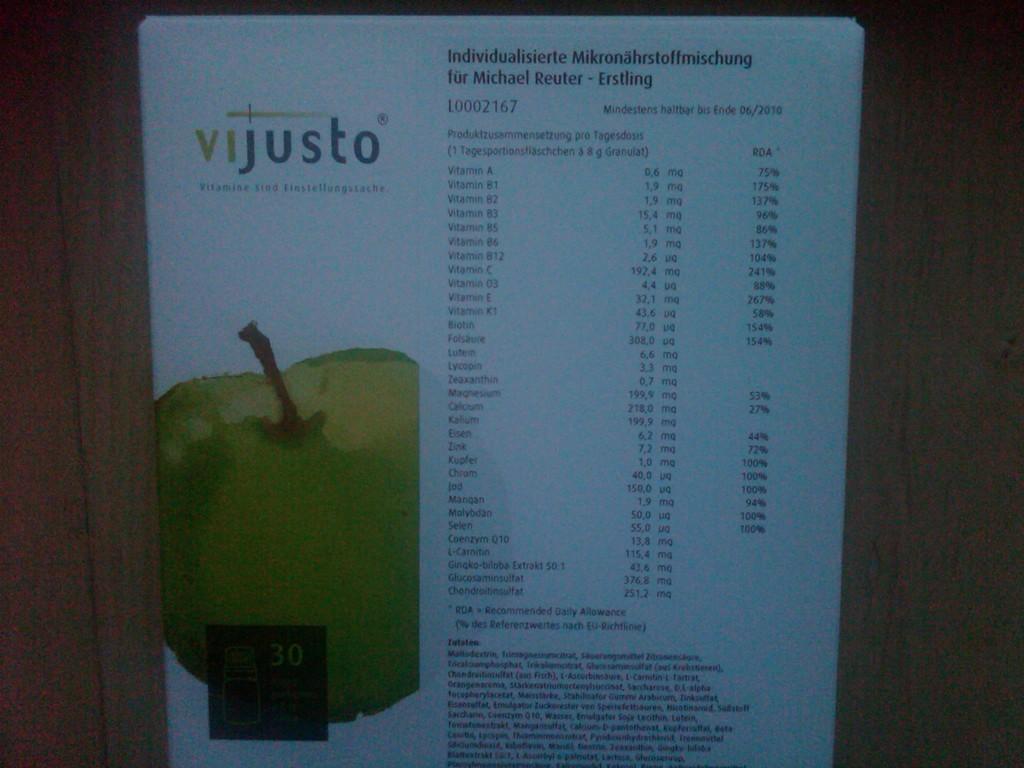What's the name above the apple?
Keep it short and to the point. Vijusto. How much vitamin a is in this product?
Keep it short and to the point. Unanswerable. 